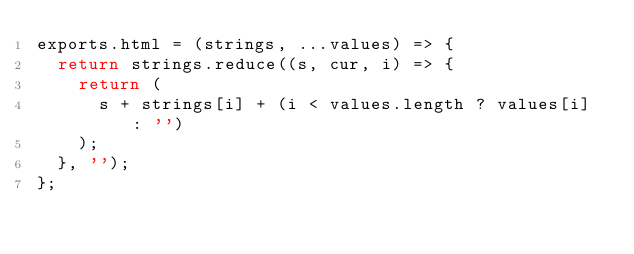<code> <loc_0><loc_0><loc_500><loc_500><_JavaScript_>exports.html = (strings, ...values) => {
  return strings.reduce((s, cur, i) => {
    return (
      s + strings[i] + (i < values.length ? values[i] : '')
    );
  }, '');
};
</code> 